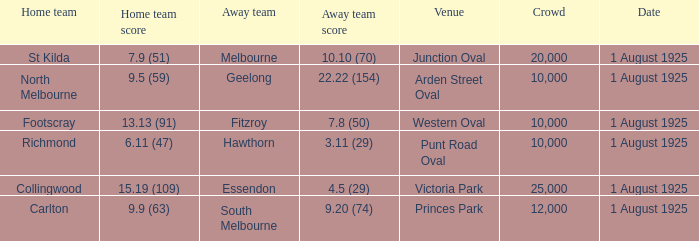When did the match take place that had a home team score of 7.9 (51)? 1 August 1925. 